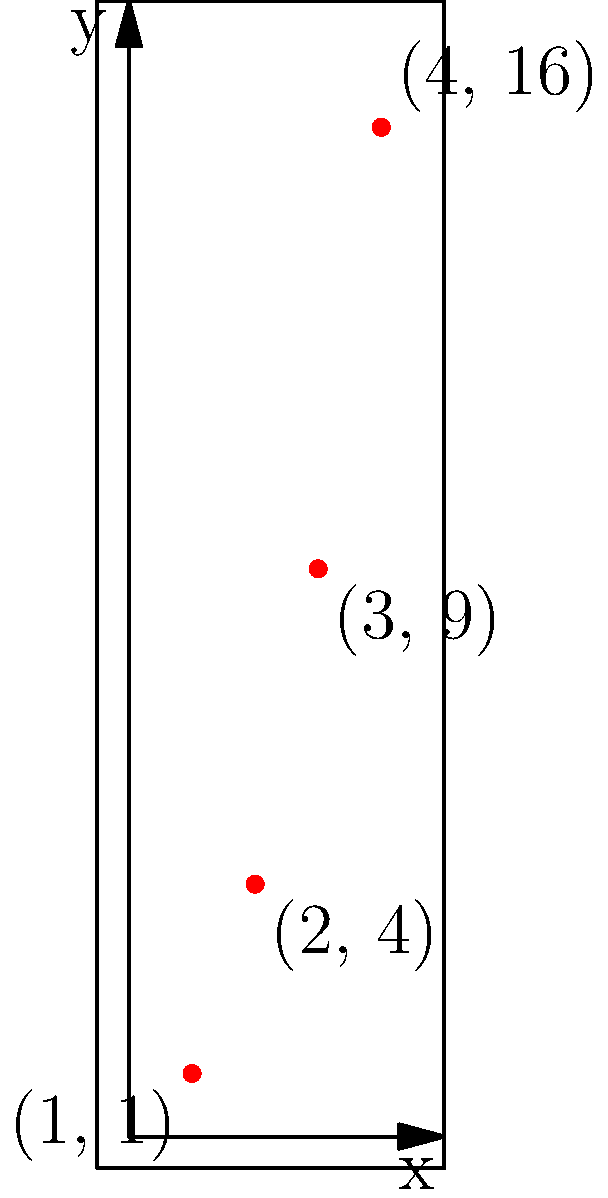Given a list of 2D coordinates $[(1, 1), (2, 2), (3, 3), (4, 4)]$, a map function is applied to transform each point $(x, y)$ into $(x, y^2)$. What is the resulting list of coordinates, and how would you implement this transformation using a higher-order function in a functional programming language? To solve this problem, we'll follow these steps:

1. Understand the transformation: For each point $(x, y)$, we need to apply the function $f(x, y) = (x, y^2)$.

2. Apply the transformation to each point:
   - $(1, 1) \rightarrow (1, 1^2) = (1, 1)$
   - $(2, 2) \rightarrow (2, 2^2) = (2, 4)$
   - $(3, 3) \rightarrow (3, 3^2) = (3, 9)$
   - $(4, 4) \rightarrow (4, 4^2) = (4, 16)$

3. The resulting list of coordinates is $[(1, 1), (2, 4), (3, 9), (4, 16)]$.

4. To implement this using a higher-order function in a functional programming language, we can use the `map` function. Here's an example in Haskell:

   ```haskell
   transform :: [(Int, Int)] -> [(Int, Int)]
   transform = map (\(x, y) -> (x, y^2))
   ```

   In this implementation, we use an anonymous function (lambda) that takes a tuple $(x, y)$ and returns a new tuple $(x, y^2)$. The `map` function applies this transformation to each element in the input list.

5. The visualization in the graph shows the resulting points after the transformation, demonstrating how the y-coordinates have been squared while the x-coordinates remain unchanged.

This approach demonstrates the power of functional programming by using higher-order functions to apply a transformation to a collection of data points in a concise and expressive manner.
Answer: $[(1, 1), (2, 4), (3, 9), (4, 16)]$; `map (\(x, y) -> (x, y^2))` 